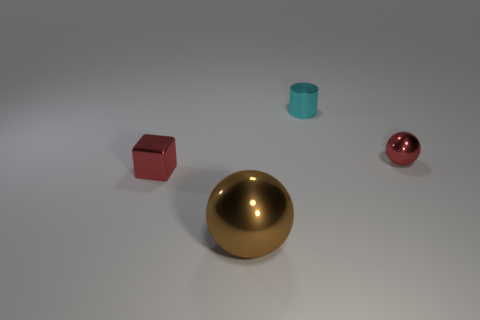Add 3 yellow metal cubes. How many objects exist? 7 Subtract all red spheres. How many spheres are left? 1 Subtract all cubes. How many objects are left? 3 Subtract 1 cylinders. How many cylinders are left? 0 Subtract all red objects. Subtract all metallic blocks. How many objects are left? 1 Add 3 big metallic spheres. How many big metallic spheres are left? 4 Add 1 yellow matte things. How many yellow matte things exist? 1 Subtract 0 yellow cylinders. How many objects are left? 4 Subtract all yellow balls. Subtract all purple cylinders. How many balls are left? 2 Subtract all blue cubes. How many brown spheres are left? 1 